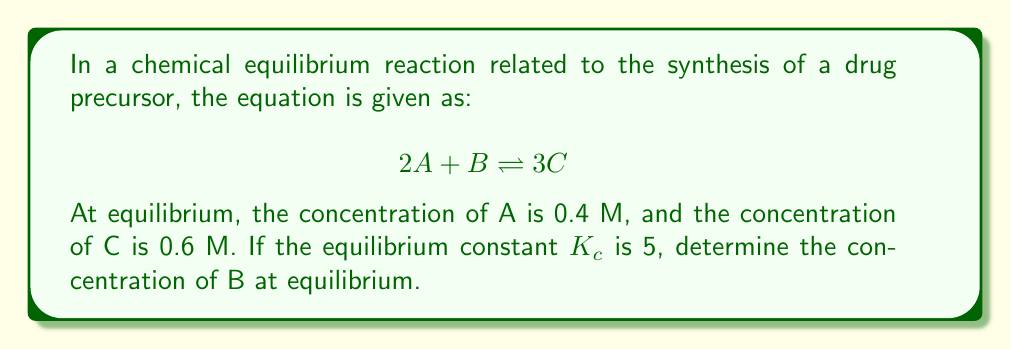What is the answer to this math problem? Let's approach this step-by-step:

1) The general form of the equilibrium constant expression for this reaction is:

   $$K_c = \frac{[C]^3}{[A]^2[B]}$$

2) We are given:
   - $[A] = 0.4$ M
   - $[C] = 0.6$ M
   - $K_c = 5$

3) Let's substitute these values into the equilibrium constant expression:

   $$5 = \frac{(0.6)^3}{(0.4)^2[B]}$$

4) Now, let's solve for [B]:

   $$5 = \frac{0.216}{0.16[B]}$$

5) Multiply both sides by $0.16[B]$:

   $$0.8[B] = 0.216$$

6) Divide both sides by 0.8:

   $$[B] = \frac{0.216}{0.8} = 0.27$$

Therefore, the concentration of B at equilibrium is 0.27 M.
Answer: $[B] = 0.27$ M 